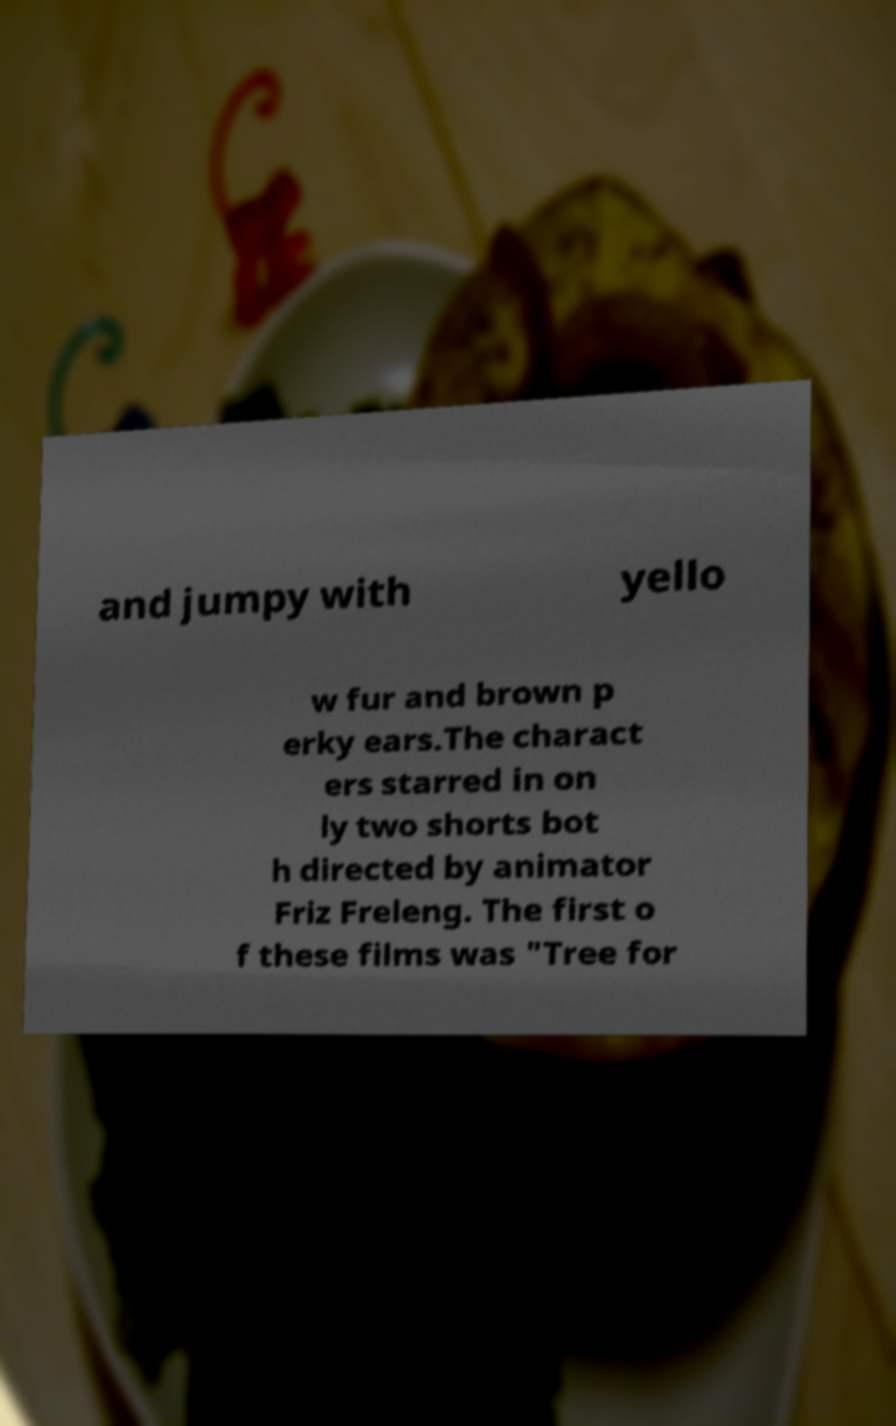Please read and relay the text visible in this image. What does it say? and jumpy with yello w fur and brown p erky ears.The charact ers starred in on ly two shorts bot h directed by animator Friz Freleng. The first o f these films was "Tree for 